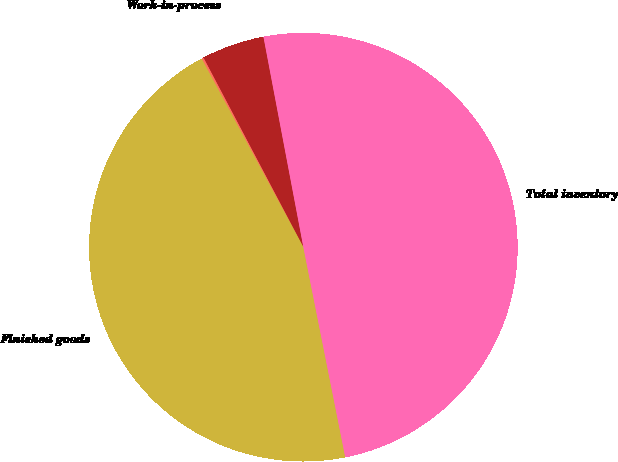<chart> <loc_0><loc_0><loc_500><loc_500><pie_chart><fcel>Raw materials<fcel>Work-in-process<fcel>Finished goods<fcel>Total inventory<nl><fcel>4.74%<fcel>0.15%<fcel>45.26%<fcel>49.85%<nl></chart> 